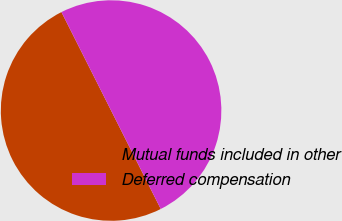Convert chart. <chart><loc_0><loc_0><loc_500><loc_500><pie_chart><fcel>Mutual funds included in other<fcel>Deferred compensation<nl><fcel>50.0%<fcel>50.0%<nl></chart> 